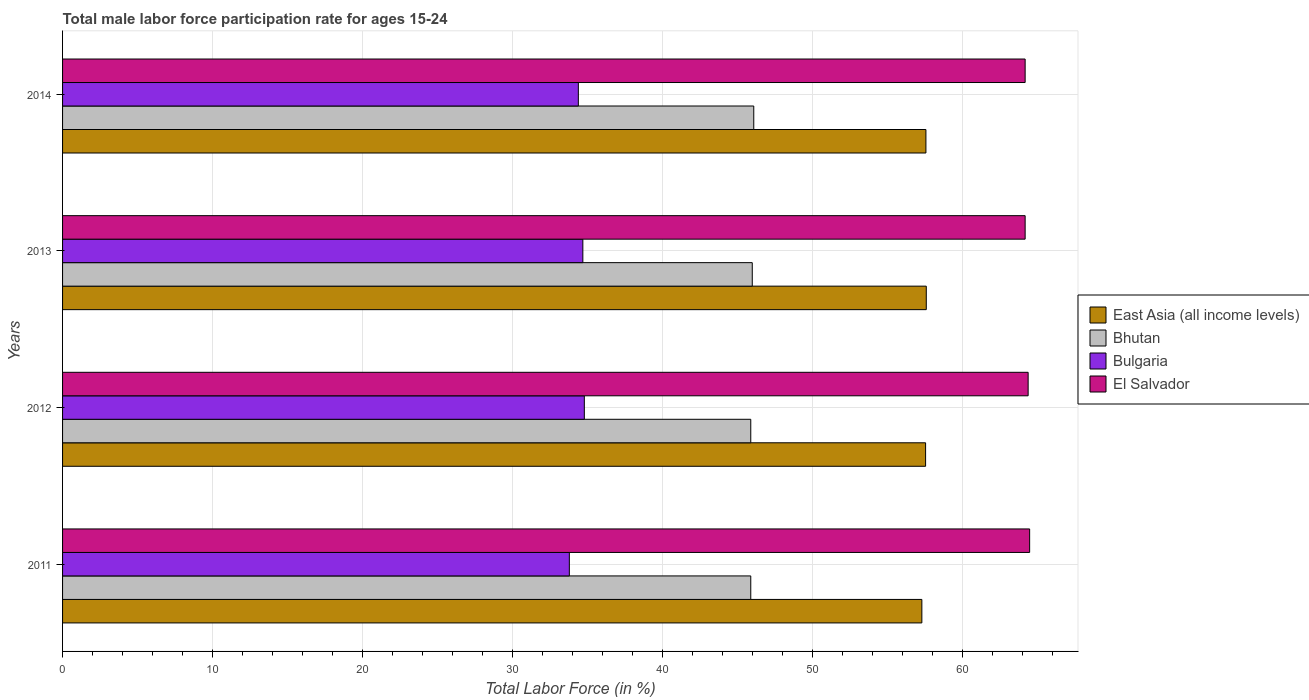How many different coloured bars are there?
Offer a very short reply. 4. Are the number of bars per tick equal to the number of legend labels?
Your answer should be compact. Yes. How many bars are there on the 3rd tick from the bottom?
Your answer should be compact. 4. In how many cases, is the number of bars for a given year not equal to the number of legend labels?
Provide a short and direct response. 0. What is the male labor force participation rate in Bulgaria in 2011?
Give a very brief answer. 33.8. Across all years, what is the maximum male labor force participation rate in El Salvador?
Your response must be concise. 64.5. Across all years, what is the minimum male labor force participation rate in East Asia (all income levels)?
Provide a succinct answer. 57.31. In which year was the male labor force participation rate in Bhutan minimum?
Provide a succinct answer. 2011. What is the total male labor force participation rate in Bhutan in the graph?
Offer a very short reply. 183.9. What is the difference between the male labor force participation rate in East Asia (all income levels) in 2011 and that in 2014?
Ensure brevity in your answer.  -0.27. What is the average male labor force participation rate in El Salvador per year?
Offer a terse response. 64.32. In the year 2012, what is the difference between the male labor force participation rate in Bhutan and male labor force participation rate in East Asia (all income levels)?
Your response must be concise. -11.66. In how many years, is the male labor force participation rate in Bhutan greater than 6 %?
Give a very brief answer. 4. What is the ratio of the male labor force participation rate in Bulgaria in 2011 to that in 2014?
Ensure brevity in your answer.  0.98. What is the difference between the highest and the second highest male labor force participation rate in Bhutan?
Give a very brief answer. 0.1. What is the difference between the highest and the lowest male labor force participation rate in El Salvador?
Your answer should be compact. 0.3. In how many years, is the male labor force participation rate in Bhutan greater than the average male labor force participation rate in Bhutan taken over all years?
Give a very brief answer. 2. Is it the case that in every year, the sum of the male labor force participation rate in East Asia (all income levels) and male labor force participation rate in El Salvador is greater than the sum of male labor force participation rate in Bulgaria and male labor force participation rate in Bhutan?
Offer a very short reply. Yes. What does the 1st bar from the top in 2014 represents?
Your answer should be very brief. El Salvador. What does the 2nd bar from the bottom in 2014 represents?
Make the answer very short. Bhutan. How many bars are there?
Keep it short and to the point. 16. Are all the bars in the graph horizontal?
Provide a short and direct response. Yes. What is the difference between two consecutive major ticks on the X-axis?
Provide a short and direct response. 10. Are the values on the major ticks of X-axis written in scientific E-notation?
Your answer should be compact. No. Does the graph contain any zero values?
Your answer should be very brief. No. Does the graph contain grids?
Provide a short and direct response. Yes. Where does the legend appear in the graph?
Make the answer very short. Center right. How are the legend labels stacked?
Ensure brevity in your answer.  Vertical. What is the title of the graph?
Your response must be concise. Total male labor force participation rate for ages 15-24. What is the label or title of the X-axis?
Your response must be concise. Total Labor Force (in %). What is the label or title of the Y-axis?
Ensure brevity in your answer.  Years. What is the Total Labor Force (in %) of East Asia (all income levels) in 2011?
Your response must be concise. 57.31. What is the Total Labor Force (in %) of Bhutan in 2011?
Your answer should be very brief. 45.9. What is the Total Labor Force (in %) in Bulgaria in 2011?
Provide a succinct answer. 33.8. What is the Total Labor Force (in %) of El Salvador in 2011?
Ensure brevity in your answer.  64.5. What is the Total Labor Force (in %) in East Asia (all income levels) in 2012?
Provide a succinct answer. 57.56. What is the Total Labor Force (in %) in Bhutan in 2012?
Provide a succinct answer. 45.9. What is the Total Labor Force (in %) of Bulgaria in 2012?
Your response must be concise. 34.8. What is the Total Labor Force (in %) in El Salvador in 2012?
Your response must be concise. 64.4. What is the Total Labor Force (in %) in East Asia (all income levels) in 2013?
Offer a terse response. 57.61. What is the Total Labor Force (in %) in Bhutan in 2013?
Keep it short and to the point. 46. What is the Total Labor Force (in %) in Bulgaria in 2013?
Ensure brevity in your answer.  34.7. What is the Total Labor Force (in %) in El Salvador in 2013?
Keep it short and to the point. 64.2. What is the Total Labor Force (in %) of East Asia (all income levels) in 2014?
Make the answer very short. 57.58. What is the Total Labor Force (in %) of Bhutan in 2014?
Offer a very short reply. 46.1. What is the Total Labor Force (in %) in Bulgaria in 2014?
Provide a short and direct response. 34.4. What is the Total Labor Force (in %) of El Salvador in 2014?
Your response must be concise. 64.2. Across all years, what is the maximum Total Labor Force (in %) in East Asia (all income levels)?
Offer a very short reply. 57.61. Across all years, what is the maximum Total Labor Force (in %) of Bhutan?
Provide a short and direct response. 46.1. Across all years, what is the maximum Total Labor Force (in %) of Bulgaria?
Give a very brief answer. 34.8. Across all years, what is the maximum Total Labor Force (in %) in El Salvador?
Your answer should be compact. 64.5. Across all years, what is the minimum Total Labor Force (in %) of East Asia (all income levels)?
Provide a short and direct response. 57.31. Across all years, what is the minimum Total Labor Force (in %) of Bhutan?
Offer a terse response. 45.9. Across all years, what is the minimum Total Labor Force (in %) in Bulgaria?
Your answer should be compact. 33.8. Across all years, what is the minimum Total Labor Force (in %) in El Salvador?
Offer a very short reply. 64.2. What is the total Total Labor Force (in %) of East Asia (all income levels) in the graph?
Your response must be concise. 230.06. What is the total Total Labor Force (in %) of Bhutan in the graph?
Your answer should be compact. 183.9. What is the total Total Labor Force (in %) of Bulgaria in the graph?
Your response must be concise. 137.7. What is the total Total Labor Force (in %) of El Salvador in the graph?
Offer a terse response. 257.3. What is the difference between the Total Labor Force (in %) in East Asia (all income levels) in 2011 and that in 2012?
Offer a terse response. -0.25. What is the difference between the Total Labor Force (in %) of El Salvador in 2011 and that in 2012?
Provide a short and direct response. 0.1. What is the difference between the Total Labor Force (in %) in East Asia (all income levels) in 2011 and that in 2013?
Keep it short and to the point. -0.3. What is the difference between the Total Labor Force (in %) of Bulgaria in 2011 and that in 2013?
Your answer should be very brief. -0.9. What is the difference between the Total Labor Force (in %) of East Asia (all income levels) in 2011 and that in 2014?
Your response must be concise. -0.27. What is the difference between the Total Labor Force (in %) of Bhutan in 2011 and that in 2014?
Keep it short and to the point. -0.2. What is the difference between the Total Labor Force (in %) of Bulgaria in 2011 and that in 2014?
Your response must be concise. -0.6. What is the difference between the Total Labor Force (in %) in El Salvador in 2011 and that in 2014?
Provide a short and direct response. 0.3. What is the difference between the Total Labor Force (in %) in East Asia (all income levels) in 2012 and that in 2013?
Make the answer very short. -0.05. What is the difference between the Total Labor Force (in %) of Bhutan in 2012 and that in 2013?
Keep it short and to the point. -0.1. What is the difference between the Total Labor Force (in %) of El Salvador in 2012 and that in 2013?
Make the answer very short. 0.2. What is the difference between the Total Labor Force (in %) of East Asia (all income levels) in 2012 and that in 2014?
Your answer should be very brief. -0.02. What is the difference between the Total Labor Force (in %) in El Salvador in 2012 and that in 2014?
Provide a short and direct response. 0.2. What is the difference between the Total Labor Force (in %) in East Asia (all income levels) in 2013 and that in 2014?
Keep it short and to the point. 0.02. What is the difference between the Total Labor Force (in %) of Bhutan in 2013 and that in 2014?
Provide a short and direct response. -0.1. What is the difference between the Total Labor Force (in %) of Bulgaria in 2013 and that in 2014?
Ensure brevity in your answer.  0.3. What is the difference between the Total Labor Force (in %) of East Asia (all income levels) in 2011 and the Total Labor Force (in %) of Bhutan in 2012?
Your response must be concise. 11.41. What is the difference between the Total Labor Force (in %) of East Asia (all income levels) in 2011 and the Total Labor Force (in %) of Bulgaria in 2012?
Offer a terse response. 22.51. What is the difference between the Total Labor Force (in %) in East Asia (all income levels) in 2011 and the Total Labor Force (in %) in El Salvador in 2012?
Your answer should be very brief. -7.09. What is the difference between the Total Labor Force (in %) of Bhutan in 2011 and the Total Labor Force (in %) of Bulgaria in 2012?
Your answer should be compact. 11.1. What is the difference between the Total Labor Force (in %) in Bhutan in 2011 and the Total Labor Force (in %) in El Salvador in 2012?
Provide a short and direct response. -18.5. What is the difference between the Total Labor Force (in %) in Bulgaria in 2011 and the Total Labor Force (in %) in El Salvador in 2012?
Your answer should be compact. -30.6. What is the difference between the Total Labor Force (in %) of East Asia (all income levels) in 2011 and the Total Labor Force (in %) of Bhutan in 2013?
Your answer should be very brief. 11.31. What is the difference between the Total Labor Force (in %) in East Asia (all income levels) in 2011 and the Total Labor Force (in %) in Bulgaria in 2013?
Your answer should be very brief. 22.61. What is the difference between the Total Labor Force (in %) in East Asia (all income levels) in 2011 and the Total Labor Force (in %) in El Salvador in 2013?
Provide a succinct answer. -6.89. What is the difference between the Total Labor Force (in %) in Bhutan in 2011 and the Total Labor Force (in %) in El Salvador in 2013?
Ensure brevity in your answer.  -18.3. What is the difference between the Total Labor Force (in %) of Bulgaria in 2011 and the Total Labor Force (in %) of El Salvador in 2013?
Provide a short and direct response. -30.4. What is the difference between the Total Labor Force (in %) of East Asia (all income levels) in 2011 and the Total Labor Force (in %) of Bhutan in 2014?
Offer a terse response. 11.21. What is the difference between the Total Labor Force (in %) of East Asia (all income levels) in 2011 and the Total Labor Force (in %) of Bulgaria in 2014?
Make the answer very short. 22.91. What is the difference between the Total Labor Force (in %) of East Asia (all income levels) in 2011 and the Total Labor Force (in %) of El Salvador in 2014?
Make the answer very short. -6.89. What is the difference between the Total Labor Force (in %) of Bhutan in 2011 and the Total Labor Force (in %) of El Salvador in 2014?
Your answer should be compact. -18.3. What is the difference between the Total Labor Force (in %) in Bulgaria in 2011 and the Total Labor Force (in %) in El Salvador in 2014?
Make the answer very short. -30.4. What is the difference between the Total Labor Force (in %) in East Asia (all income levels) in 2012 and the Total Labor Force (in %) in Bhutan in 2013?
Offer a very short reply. 11.56. What is the difference between the Total Labor Force (in %) in East Asia (all income levels) in 2012 and the Total Labor Force (in %) in Bulgaria in 2013?
Provide a short and direct response. 22.86. What is the difference between the Total Labor Force (in %) in East Asia (all income levels) in 2012 and the Total Labor Force (in %) in El Salvador in 2013?
Offer a very short reply. -6.64. What is the difference between the Total Labor Force (in %) of Bhutan in 2012 and the Total Labor Force (in %) of Bulgaria in 2013?
Your answer should be very brief. 11.2. What is the difference between the Total Labor Force (in %) in Bhutan in 2012 and the Total Labor Force (in %) in El Salvador in 2013?
Offer a terse response. -18.3. What is the difference between the Total Labor Force (in %) of Bulgaria in 2012 and the Total Labor Force (in %) of El Salvador in 2013?
Make the answer very short. -29.4. What is the difference between the Total Labor Force (in %) of East Asia (all income levels) in 2012 and the Total Labor Force (in %) of Bhutan in 2014?
Ensure brevity in your answer.  11.46. What is the difference between the Total Labor Force (in %) in East Asia (all income levels) in 2012 and the Total Labor Force (in %) in Bulgaria in 2014?
Give a very brief answer. 23.16. What is the difference between the Total Labor Force (in %) in East Asia (all income levels) in 2012 and the Total Labor Force (in %) in El Salvador in 2014?
Make the answer very short. -6.64. What is the difference between the Total Labor Force (in %) in Bhutan in 2012 and the Total Labor Force (in %) in El Salvador in 2014?
Offer a very short reply. -18.3. What is the difference between the Total Labor Force (in %) in Bulgaria in 2012 and the Total Labor Force (in %) in El Salvador in 2014?
Offer a very short reply. -29.4. What is the difference between the Total Labor Force (in %) of East Asia (all income levels) in 2013 and the Total Labor Force (in %) of Bhutan in 2014?
Your answer should be compact. 11.51. What is the difference between the Total Labor Force (in %) of East Asia (all income levels) in 2013 and the Total Labor Force (in %) of Bulgaria in 2014?
Offer a terse response. 23.21. What is the difference between the Total Labor Force (in %) in East Asia (all income levels) in 2013 and the Total Labor Force (in %) in El Salvador in 2014?
Offer a terse response. -6.59. What is the difference between the Total Labor Force (in %) of Bhutan in 2013 and the Total Labor Force (in %) of Bulgaria in 2014?
Keep it short and to the point. 11.6. What is the difference between the Total Labor Force (in %) of Bhutan in 2013 and the Total Labor Force (in %) of El Salvador in 2014?
Provide a succinct answer. -18.2. What is the difference between the Total Labor Force (in %) of Bulgaria in 2013 and the Total Labor Force (in %) of El Salvador in 2014?
Provide a succinct answer. -29.5. What is the average Total Labor Force (in %) in East Asia (all income levels) per year?
Provide a short and direct response. 57.52. What is the average Total Labor Force (in %) in Bhutan per year?
Your response must be concise. 45.98. What is the average Total Labor Force (in %) in Bulgaria per year?
Keep it short and to the point. 34.42. What is the average Total Labor Force (in %) in El Salvador per year?
Your answer should be very brief. 64.33. In the year 2011, what is the difference between the Total Labor Force (in %) of East Asia (all income levels) and Total Labor Force (in %) of Bhutan?
Your answer should be compact. 11.41. In the year 2011, what is the difference between the Total Labor Force (in %) of East Asia (all income levels) and Total Labor Force (in %) of Bulgaria?
Make the answer very short. 23.51. In the year 2011, what is the difference between the Total Labor Force (in %) in East Asia (all income levels) and Total Labor Force (in %) in El Salvador?
Provide a short and direct response. -7.19. In the year 2011, what is the difference between the Total Labor Force (in %) in Bhutan and Total Labor Force (in %) in El Salvador?
Ensure brevity in your answer.  -18.6. In the year 2011, what is the difference between the Total Labor Force (in %) in Bulgaria and Total Labor Force (in %) in El Salvador?
Give a very brief answer. -30.7. In the year 2012, what is the difference between the Total Labor Force (in %) of East Asia (all income levels) and Total Labor Force (in %) of Bhutan?
Ensure brevity in your answer.  11.66. In the year 2012, what is the difference between the Total Labor Force (in %) of East Asia (all income levels) and Total Labor Force (in %) of Bulgaria?
Make the answer very short. 22.76. In the year 2012, what is the difference between the Total Labor Force (in %) of East Asia (all income levels) and Total Labor Force (in %) of El Salvador?
Give a very brief answer. -6.84. In the year 2012, what is the difference between the Total Labor Force (in %) of Bhutan and Total Labor Force (in %) of El Salvador?
Ensure brevity in your answer.  -18.5. In the year 2012, what is the difference between the Total Labor Force (in %) in Bulgaria and Total Labor Force (in %) in El Salvador?
Your response must be concise. -29.6. In the year 2013, what is the difference between the Total Labor Force (in %) of East Asia (all income levels) and Total Labor Force (in %) of Bhutan?
Offer a very short reply. 11.61. In the year 2013, what is the difference between the Total Labor Force (in %) of East Asia (all income levels) and Total Labor Force (in %) of Bulgaria?
Your answer should be compact. 22.91. In the year 2013, what is the difference between the Total Labor Force (in %) in East Asia (all income levels) and Total Labor Force (in %) in El Salvador?
Your response must be concise. -6.59. In the year 2013, what is the difference between the Total Labor Force (in %) in Bhutan and Total Labor Force (in %) in Bulgaria?
Provide a short and direct response. 11.3. In the year 2013, what is the difference between the Total Labor Force (in %) of Bhutan and Total Labor Force (in %) of El Salvador?
Provide a succinct answer. -18.2. In the year 2013, what is the difference between the Total Labor Force (in %) of Bulgaria and Total Labor Force (in %) of El Salvador?
Provide a succinct answer. -29.5. In the year 2014, what is the difference between the Total Labor Force (in %) of East Asia (all income levels) and Total Labor Force (in %) of Bhutan?
Your response must be concise. 11.48. In the year 2014, what is the difference between the Total Labor Force (in %) in East Asia (all income levels) and Total Labor Force (in %) in Bulgaria?
Give a very brief answer. 23.18. In the year 2014, what is the difference between the Total Labor Force (in %) in East Asia (all income levels) and Total Labor Force (in %) in El Salvador?
Provide a short and direct response. -6.62. In the year 2014, what is the difference between the Total Labor Force (in %) in Bhutan and Total Labor Force (in %) in Bulgaria?
Offer a terse response. 11.7. In the year 2014, what is the difference between the Total Labor Force (in %) of Bhutan and Total Labor Force (in %) of El Salvador?
Offer a very short reply. -18.1. In the year 2014, what is the difference between the Total Labor Force (in %) of Bulgaria and Total Labor Force (in %) of El Salvador?
Keep it short and to the point. -29.8. What is the ratio of the Total Labor Force (in %) of Bhutan in 2011 to that in 2012?
Your response must be concise. 1. What is the ratio of the Total Labor Force (in %) in Bulgaria in 2011 to that in 2012?
Provide a short and direct response. 0.97. What is the ratio of the Total Labor Force (in %) in Bhutan in 2011 to that in 2013?
Offer a very short reply. 1. What is the ratio of the Total Labor Force (in %) in Bulgaria in 2011 to that in 2013?
Ensure brevity in your answer.  0.97. What is the ratio of the Total Labor Force (in %) in East Asia (all income levels) in 2011 to that in 2014?
Make the answer very short. 1. What is the ratio of the Total Labor Force (in %) of Bhutan in 2011 to that in 2014?
Offer a terse response. 1. What is the ratio of the Total Labor Force (in %) in Bulgaria in 2011 to that in 2014?
Your answer should be compact. 0.98. What is the ratio of the Total Labor Force (in %) in East Asia (all income levels) in 2012 to that in 2013?
Ensure brevity in your answer.  1. What is the ratio of the Total Labor Force (in %) of Bulgaria in 2012 to that in 2013?
Offer a very short reply. 1. What is the ratio of the Total Labor Force (in %) of Bhutan in 2012 to that in 2014?
Provide a short and direct response. 1. What is the ratio of the Total Labor Force (in %) in Bulgaria in 2012 to that in 2014?
Your response must be concise. 1.01. What is the ratio of the Total Labor Force (in %) in El Salvador in 2012 to that in 2014?
Your answer should be very brief. 1. What is the ratio of the Total Labor Force (in %) in Bulgaria in 2013 to that in 2014?
Ensure brevity in your answer.  1.01. What is the difference between the highest and the second highest Total Labor Force (in %) of East Asia (all income levels)?
Provide a short and direct response. 0.02. What is the difference between the highest and the second highest Total Labor Force (in %) in Bhutan?
Ensure brevity in your answer.  0.1. What is the difference between the highest and the second highest Total Labor Force (in %) of Bulgaria?
Make the answer very short. 0.1. What is the difference between the highest and the lowest Total Labor Force (in %) in East Asia (all income levels)?
Provide a short and direct response. 0.3. 